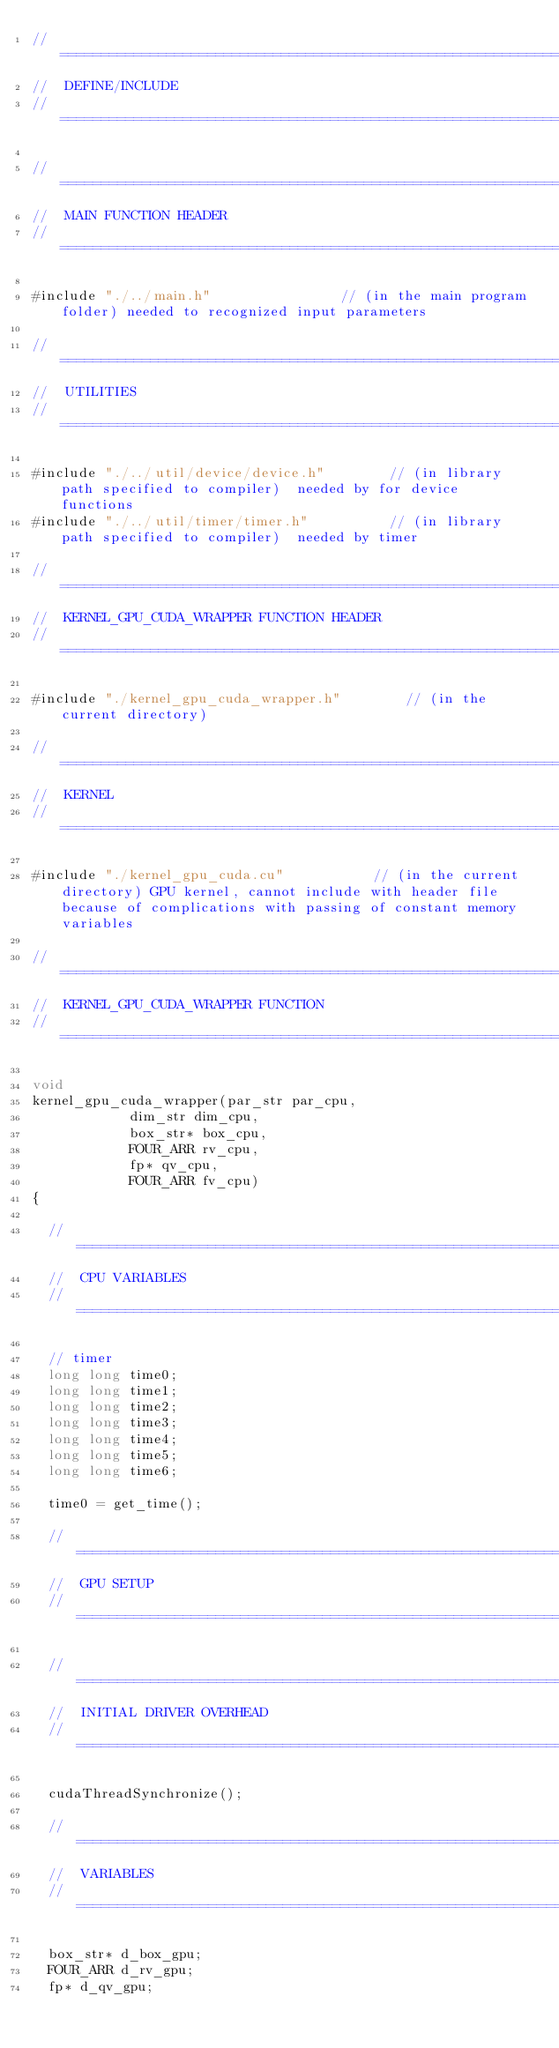Convert code to text. <code><loc_0><loc_0><loc_500><loc_500><_Cuda_>//========================================================================================================================================================================================================200
//	DEFINE/INCLUDE
//========================================================================================================================================================================================================200

//======================================================================================================================================================150
//	MAIN FUNCTION HEADER
//======================================================================================================================================================150

#include "./../main.h"								// (in the main program folder)	needed to recognized input parameters

//======================================================================================================================================================150
//	UTILITIES
//======================================================================================================================================================150

#include "./../util/device/device.h"				// (in library path specified to compiler)	needed by for device functions
#include "./../util/timer/timer.h"					// (in library path specified to compiler)	needed by timer

//======================================================================================================================================================150
//	KERNEL_GPU_CUDA_WRAPPER FUNCTION HEADER
//======================================================================================================================================================150

#include "./kernel_gpu_cuda_wrapper.h"				// (in the current directory)

//======================================================================================================================================================150
//	KERNEL
//======================================================================================================================================================150

#include "./kernel_gpu_cuda.cu"						// (in the current directory)	GPU kernel, cannot include with header file because of complications with passing of constant memory variables

//========================================================================================================================================================================================================200
//	KERNEL_GPU_CUDA_WRAPPER FUNCTION
//========================================================================================================================================================================================================200

void
kernel_gpu_cuda_wrapper(par_str par_cpu,
						dim_str dim_cpu,
						box_str* box_cpu,
						FOUR_ARR rv_cpu,
						fp* qv_cpu,
						FOUR_ARR fv_cpu)
{

	//======================================================================================================================================================150
	//	CPU VARIABLES
	//======================================================================================================================================================150

	// timer
	long long time0;
	long long time1;
	long long time2;
	long long time3;
	long long time4;
	long long time5;
	long long time6;

	time0 = get_time();

	//======================================================================================================================================================150
	//	GPU SETUP
	//======================================================================================================================================================150

	//====================================================================================================100
	//	INITIAL DRIVER OVERHEAD
	//====================================================================================================100

	cudaThreadSynchronize();

	//====================================================================================================100
	//	VARIABLES
	//====================================================================================================100

	box_str* d_box_gpu;
	FOUR_ARR d_rv_gpu;
	fp* d_qv_gpu;</code> 